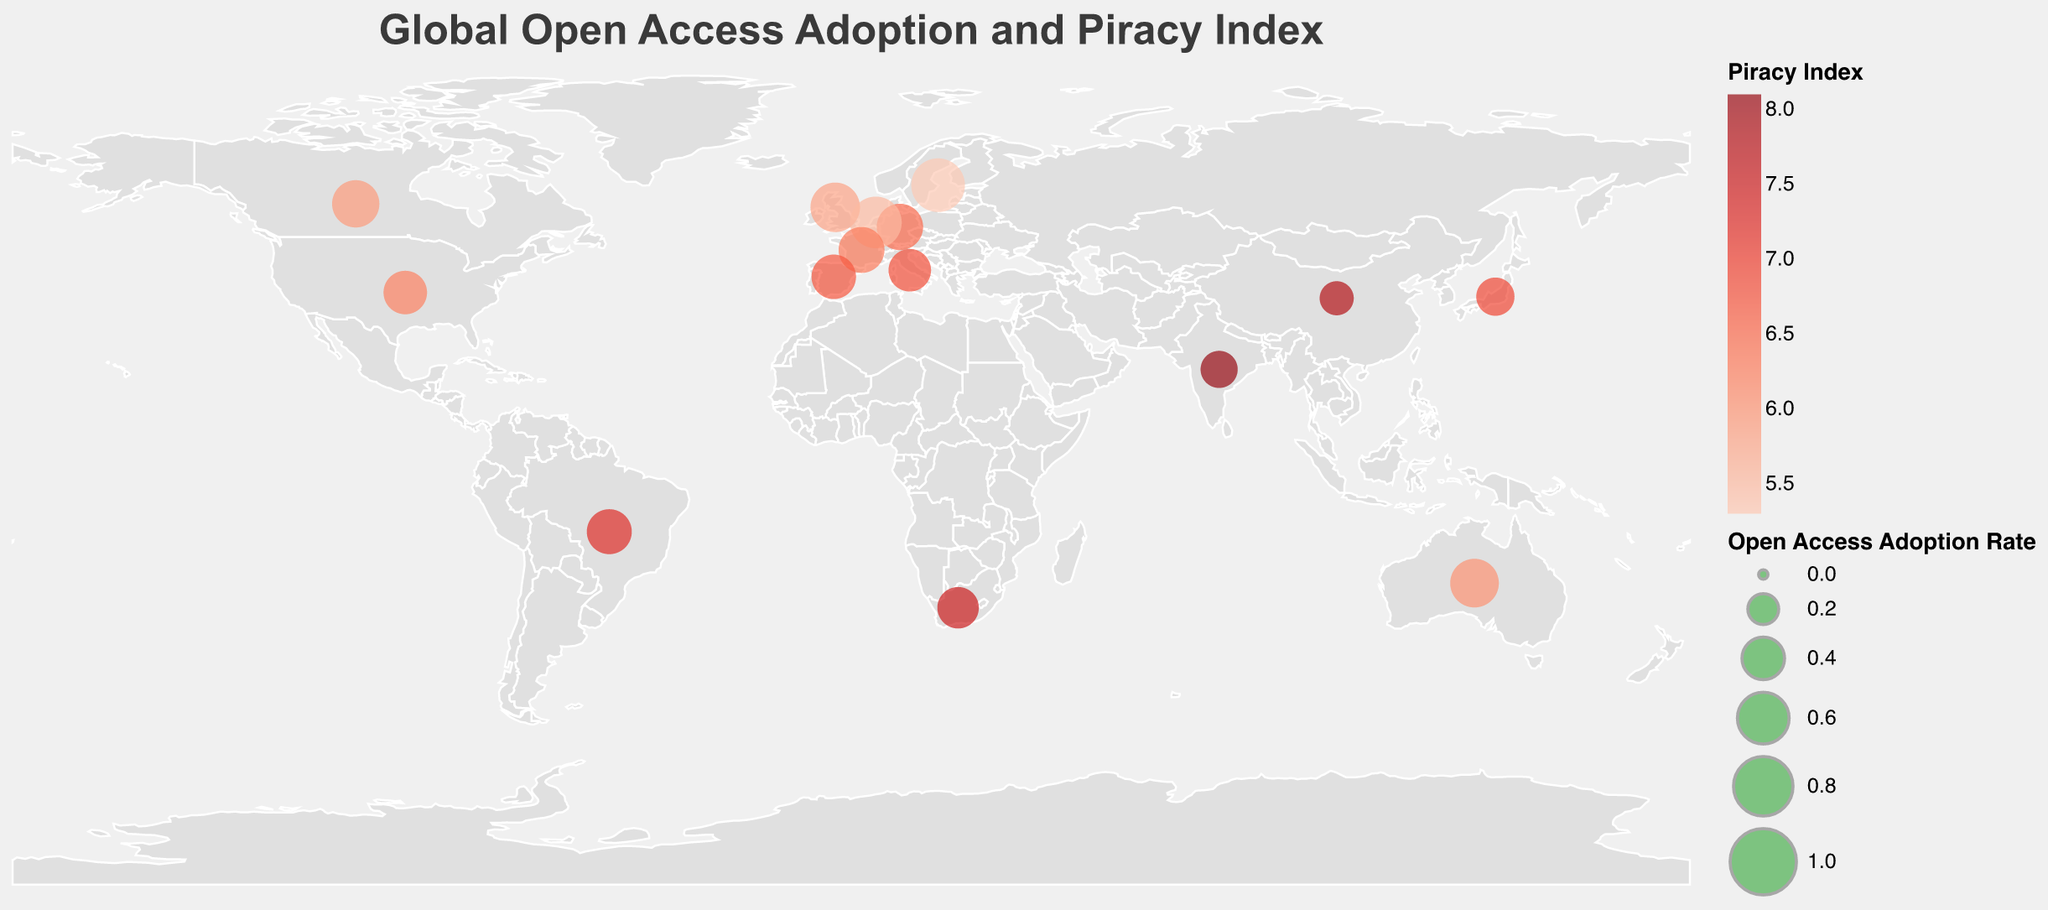What is the title of the figure? The title is the text at the top of the figure, which summarizes the content of the plot.
Answer: Global Open Access Adoption and Piracy Index How many countries are represented in the figure? By counting the number of circles, each representing a country, we can determine the total number of countries.
Answer: 15 Which country has the highest open access adoption rate? The size of the circles indicates the open access adoption rate. The largest circle represents the country with the highest rate.
Answer: Sweden Which country has the lowest open access adoption rate? The size of the circles indicates the open access adoption rate. The smallest circle represents the country with the lowest rate.
Answer: China What is the color scheme used to represent the piracy index? The color scale uses different shades of red to represent the piracy index, with darker shades indicating higher values.
Answer: Reds Which country has the highest piracy index? The color of the circles indicates the piracy index. The circle with the darkest shade of red represents the highest piracy index.
Answer: India Compare the open access adoption rates between the United States and the United Kingdom. Which is higher? By comparing the sizes of the circles representing the United States and the United Kingdom, the larger circle indicates a higher open access adoption rate.
Answer: United Kingdom What is the average piracy index of the countries in the figure? To find the average, sum the piracy indexes of all countries and divide by the number of countries: (6.2 + 5.8 + 6.5 + 5.5 + 5.3 + 7.8 + 6.9 + 7.2 + 7.5 + 6.0 + 8.1 + 5.9 + 6.3 + 6.7 + 6.8) / 15 = 6.5
Answer: 6.5 Which two countries have the same policy strength but different open access adoption rates? By examining the 'Policy Strength' values and comparing the 'Open Access Adoption Rate' among countries, identify pairs with matching policy strength but differing adoption rates.
Answer: Netherlands and Sweden / France and Spain 